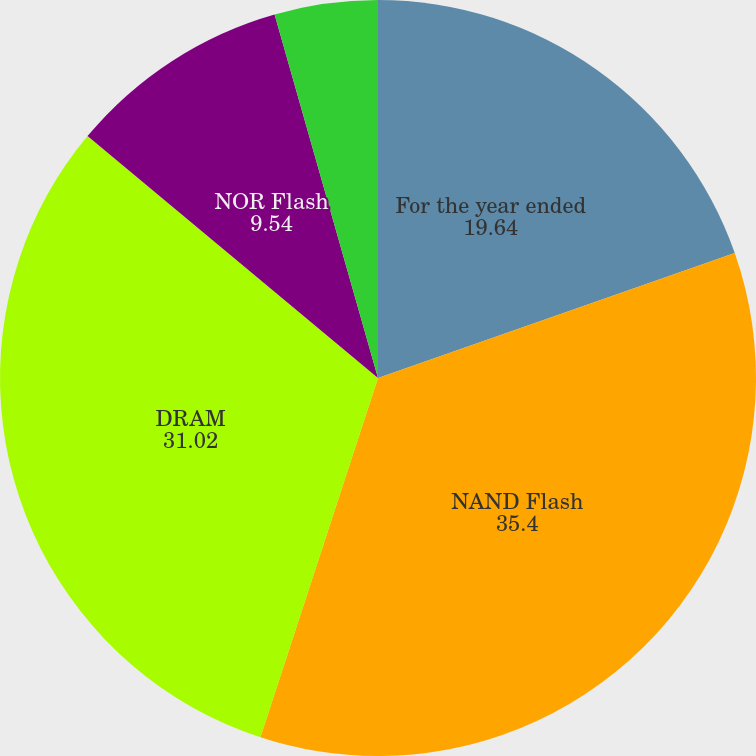Convert chart to OTSL. <chart><loc_0><loc_0><loc_500><loc_500><pie_chart><fcel>For the year ended<fcel>NAND Flash<fcel>DRAM<fcel>NOR Flash<fcel>Other<nl><fcel>19.64%<fcel>35.4%<fcel>31.02%<fcel>9.54%<fcel>4.41%<nl></chart> 